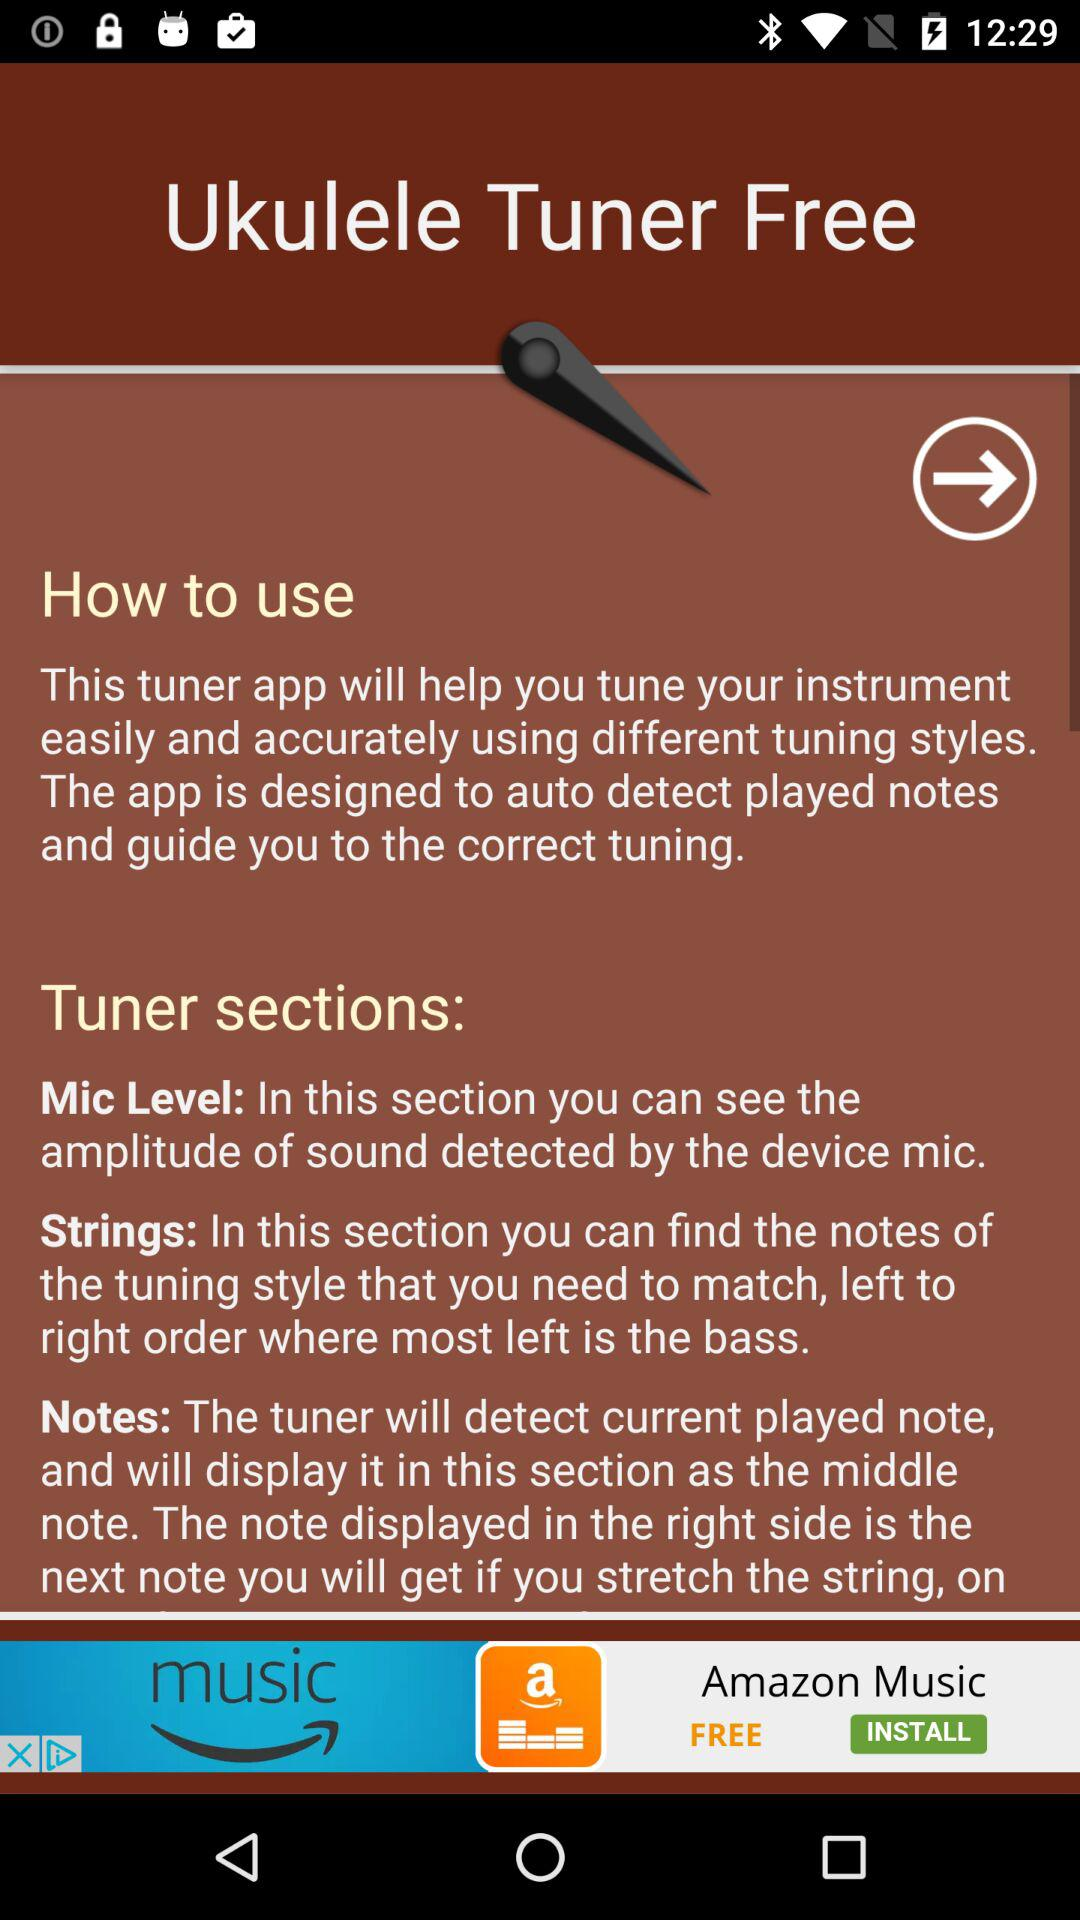How many sections does the tuner have?
Answer the question using a single word or phrase. 3 